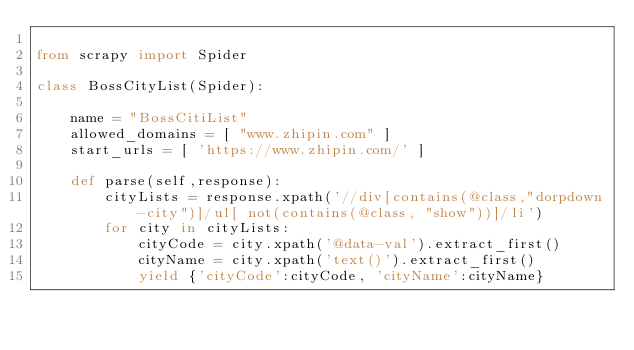<code> <loc_0><loc_0><loc_500><loc_500><_Python_>
from scrapy import Spider

class BossCityList(Spider):

    name = "BossCitiList"
    allowed_domains = [ "www.zhipin.com" ]
    start_urls = [ 'https://www.zhipin.com/' ]

    def parse(self,response):
        cityLists = response.xpath('//div[contains(@class,"dorpdown-city")]/ul[ not(contains(@class, "show"))]/li')
        for city in cityLists:
            cityCode = city.xpath('@data-val').extract_first()
            cityName = city.xpath('text()').extract_first()
            yield {'cityCode':cityCode, 'cityName':cityName}


</code> 